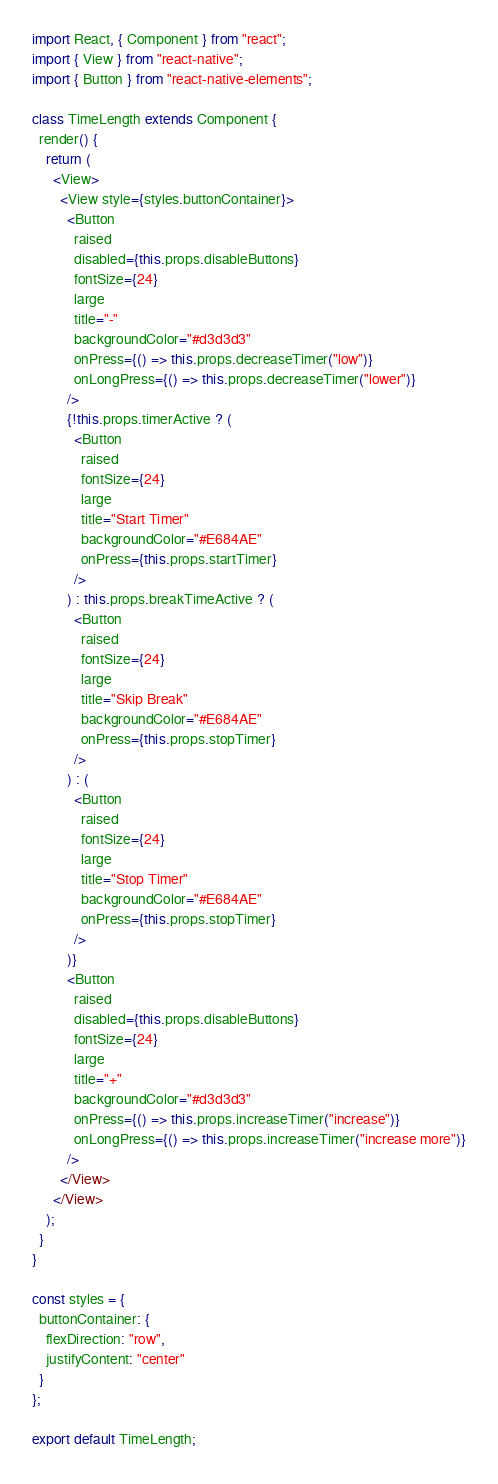Convert code to text. <code><loc_0><loc_0><loc_500><loc_500><_JavaScript_>import React, { Component } from "react";
import { View } from "react-native";
import { Button } from "react-native-elements";

class TimeLength extends Component {
  render() {
    return (
      <View>
        <View style={styles.buttonContainer}>
          <Button
            raised
            disabled={this.props.disableButtons}
            fontSize={24}
            large
            title="-"
            backgroundColor="#d3d3d3"
            onPress={() => this.props.decreaseTimer("low")}
            onLongPress={() => this.props.decreaseTimer("lower")}
          />
          {!this.props.timerActive ? (
            <Button
              raised
              fontSize={24}
              large
              title="Start Timer"
              backgroundColor="#E684AE"
              onPress={this.props.startTimer}
            />
          ) : this.props.breakTimeActive ? (
            <Button
              raised
              fontSize={24}
              large
              title="Skip Break"
              backgroundColor="#E684AE"
              onPress={this.props.stopTimer}
            />
          ) : (
            <Button
              raised
              fontSize={24}
              large
              title="Stop Timer"
              backgroundColor="#E684AE"
              onPress={this.props.stopTimer}
            />
          )}
          <Button
            raised
            disabled={this.props.disableButtons}
            fontSize={24}
            large
            title="+"
            backgroundColor="#d3d3d3"
            onPress={() => this.props.increaseTimer("increase")}
            onLongPress={() => this.props.increaseTimer("increase more")}
          />
        </View>
      </View>
    );
  }
}

const styles = {
  buttonContainer: {
    flexDirection: "row",
    justifyContent: "center"
  }
};

export default TimeLength;
</code> 